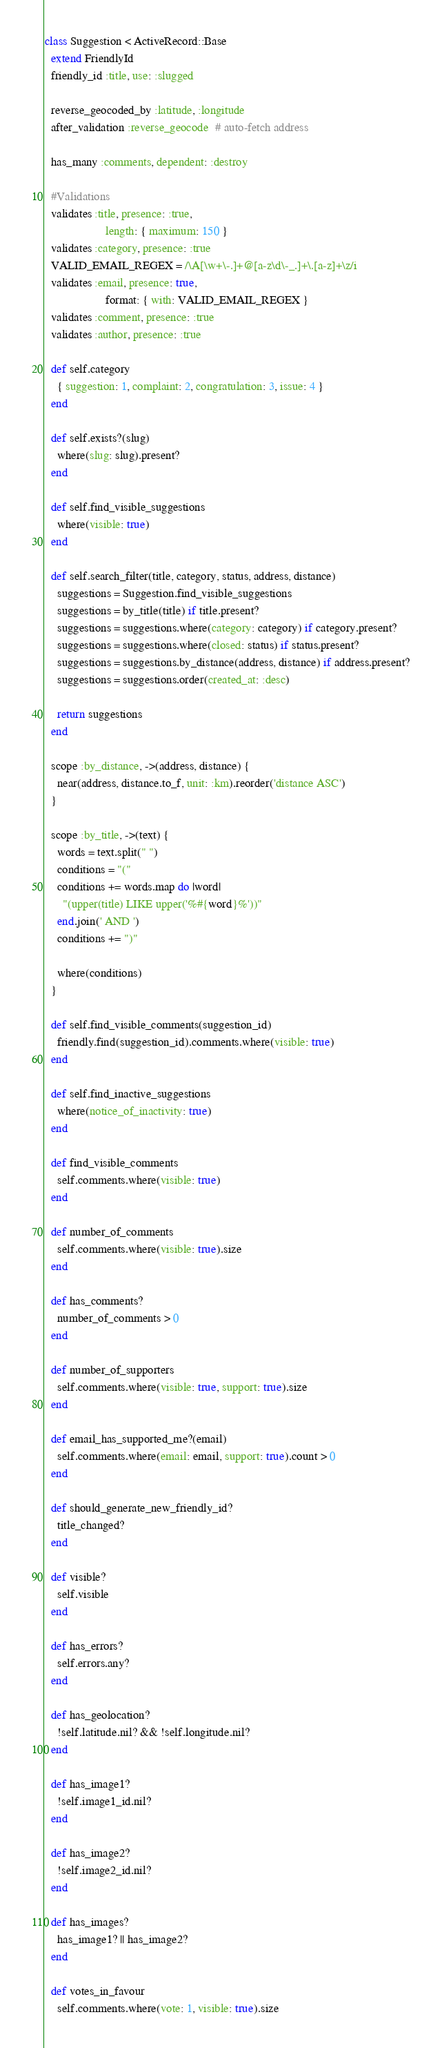Convert code to text. <code><loc_0><loc_0><loc_500><loc_500><_Ruby_>class Suggestion < ActiveRecord::Base
  extend FriendlyId
  friendly_id :title, use: :slugged

  reverse_geocoded_by :latitude, :longitude
  after_validation :reverse_geocode  # auto-fetch address

  has_many :comments, dependent: :destroy

  #Validations
  validates :title, presence: :true,
                    length: { maximum: 150 }
  validates :category, presence: :true
  VALID_EMAIL_REGEX = /\A[\w+\-.]+@[a-z\d\-_.]+\.[a-z]+\z/i
  validates :email, presence: true,
                    format: { with: VALID_EMAIL_REGEX }
  validates :comment, presence: :true
  validates :author, presence: :true

  def self.category
    { suggestion: 1, complaint: 2, congratulation: 3, issue: 4 }
  end

  def self.exists?(slug)
    where(slug: slug).present?
  end

  def self.find_visible_suggestions
    where(visible: true)
  end

  def self.search_filter(title, category, status, address, distance)
    suggestions = Suggestion.find_visible_suggestions
    suggestions = by_title(title) if title.present?
    suggestions = suggestions.where(category: category) if category.present?
    suggestions = suggestions.where(closed: status) if status.present?
    suggestions = suggestions.by_distance(address, distance) if address.present?
    suggestions = suggestions.order(created_at: :desc)

    return suggestions
  end

  scope :by_distance, ->(address, distance) {
    near(address, distance.to_f, unit: :km).reorder('distance ASC')
  }

  scope :by_title, ->(text) {
    words = text.split(" ")
    conditions = "("
    conditions += words.map do |word|
      "(upper(title) LIKE upper('%#{word}%'))"
    end.join(' AND ')
    conditions += ")"

    where(conditions)
  }

  def self.find_visible_comments(suggestion_id)
    friendly.find(suggestion_id).comments.where(visible: true)
  end

  def self.find_inactive_suggestions
    where(notice_of_inactivity: true)
  end

  def find_visible_comments
    self.comments.where(visible: true)
  end

  def number_of_comments
    self.comments.where(visible: true).size
  end

  def has_comments?
    number_of_comments > 0
  end

  def number_of_supporters
    self.comments.where(visible: true, support: true).size
  end

  def email_has_supported_me?(email)
    self.comments.where(email: email, support: true).count > 0
  end

  def should_generate_new_friendly_id?
    title_changed?
  end

  def visible?
    self.visible
  end

  def has_errors?
    self.errors.any?
  end

  def has_geolocation?
    !self.latitude.nil? && !self.longitude.nil?
  end

  def has_image1?
    !self.image1_id.nil?
  end

  def has_image2?
    !self.image2_id.nil?
  end

  def has_images?
    has_image1? || has_image2?
  end

  def votes_in_favour
    self.comments.where(vote: 1, visible: true).size</code> 